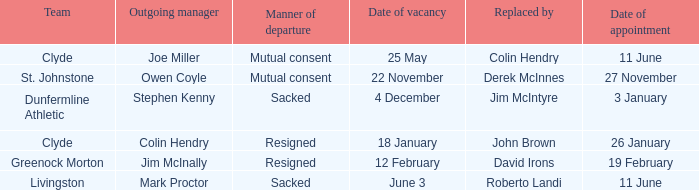Tell me the manner of departure for 3 january date of appointment Sacked. 